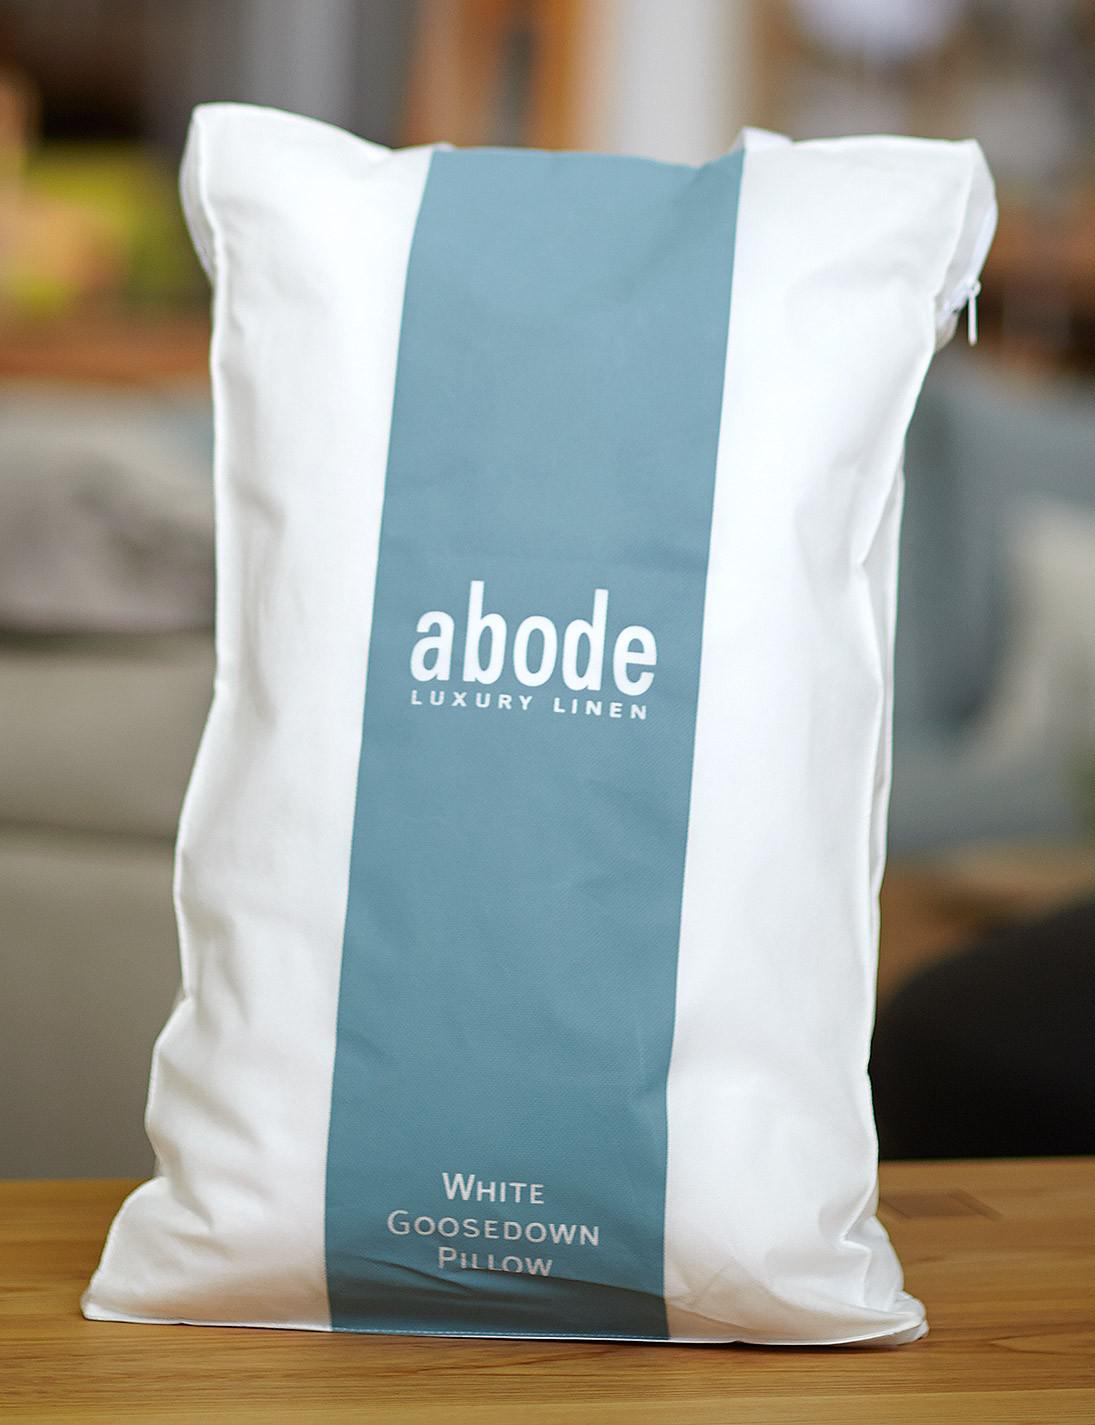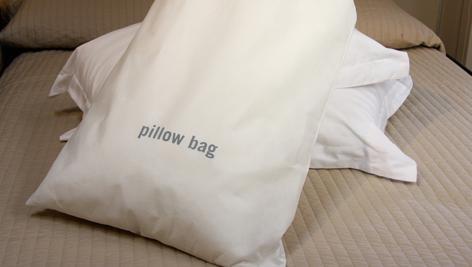The first image is the image on the left, the second image is the image on the right. Assess this claim about the two images: "One image shows an upright pillow shape with a wide blue stripe down the center, and the other image includes an off-white pillow shape with no stripe.". Correct or not? Answer yes or no. Yes. 